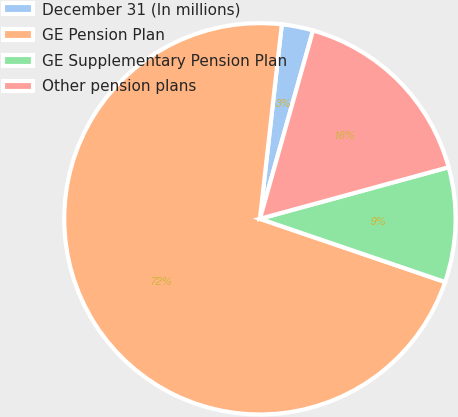Convert chart. <chart><loc_0><loc_0><loc_500><loc_500><pie_chart><fcel>December 31 (In millions)<fcel>GE Pension Plan<fcel>GE Supplementary Pension Plan<fcel>Other pension plans<nl><fcel>2.59%<fcel>71.55%<fcel>9.48%<fcel>16.38%<nl></chart> 